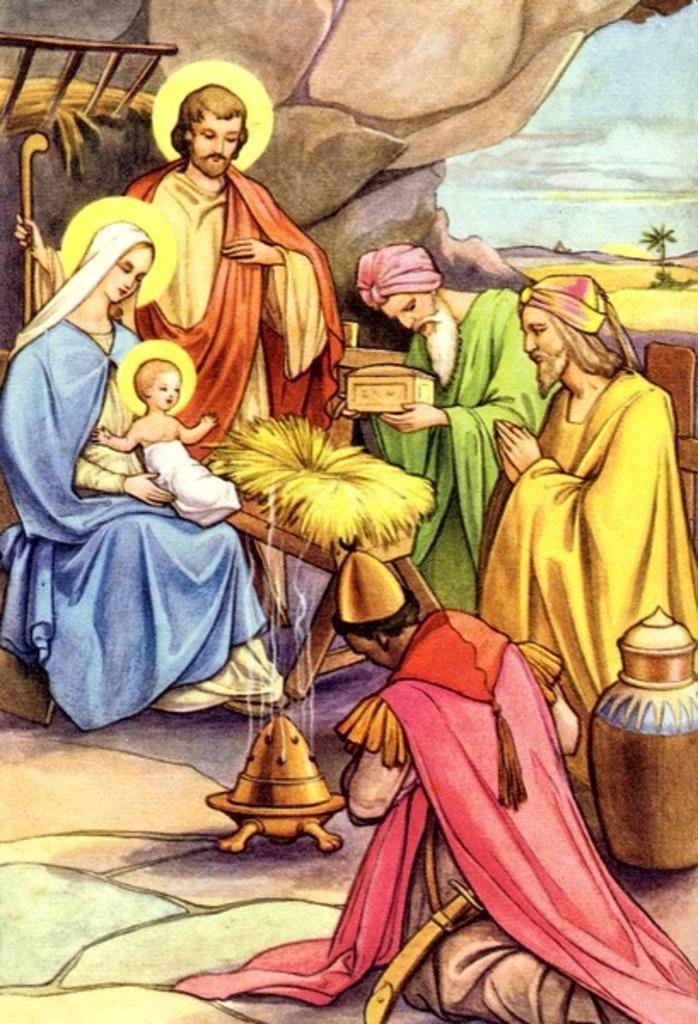How would you summarize this image in a sentence or two? In this image I can see the group of people with different color dresses. I can see one person holding the box and one person with the stick. In-front of these people I can see the smoke from the brown color object. To the right I can see the pot. In the background I can see the ladder, stones, plant and the sky. 